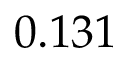Convert formula to latex. <formula><loc_0><loc_0><loc_500><loc_500>0 . 1 3 1</formula> 